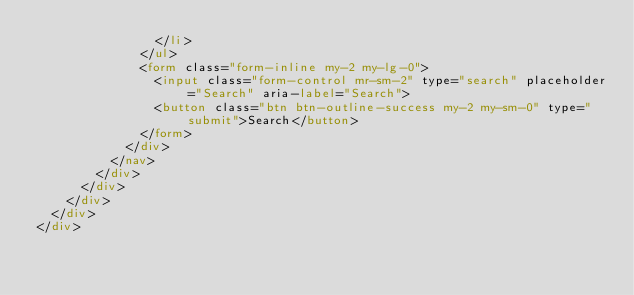<code> <loc_0><loc_0><loc_500><loc_500><_HTML_>                </li>
              </ul>
              <form class="form-inline my-2 my-lg-0">
                <input class="form-control mr-sm-2" type="search" placeholder="Search" aria-label="Search">
                <button class="btn btn-outline-success my-2 my-sm-0" type="submit">Search</button>
              </form>
            </div>
          </nav>
        </div>
      </div>
    </div>
  </div>
</div>
</code> 